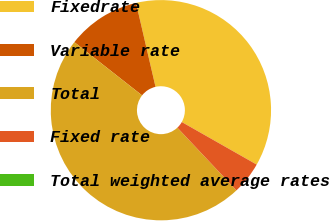Convert chart. <chart><loc_0><loc_0><loc_500><loc_500><pie_chart><fcel>Fixedrate<fcel>Variable rate<fcel>Total<fcel>Fixed rate<fcel>Total weighted average rates<nl><fcel>36.85%<fcel>10.77%<fcel>47.62%<fcel>4.76%<fcel>0.0%<nl></chart> 